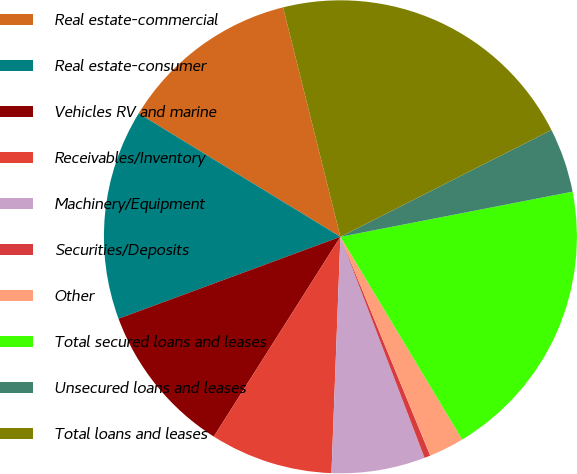Convert chart. <chart><loc_0><loc_0><loc_500><loc_500><pie_chart><fcel>Real estate-commercial<fcel>Real estate-consumer<fcel>Vehicles RV and marine<fcel>Receivables/Inventory<fcel>Machinery/Equipment<fcel>Securities/Deposits<fcel>Other<fcel>Total secured loans and leases<fcel>Unsecured loans and leases<fcel>Total loans and leases<nl><fcel>12.37%<fcel>14.36%<fcel>10.38%<fcel>8.39%<fcel>6.39%<fcel>0.41%<fcel>2.41%<fcel>19.45%<fcel>4.4%<fcel>21.44%<nl></chart> 